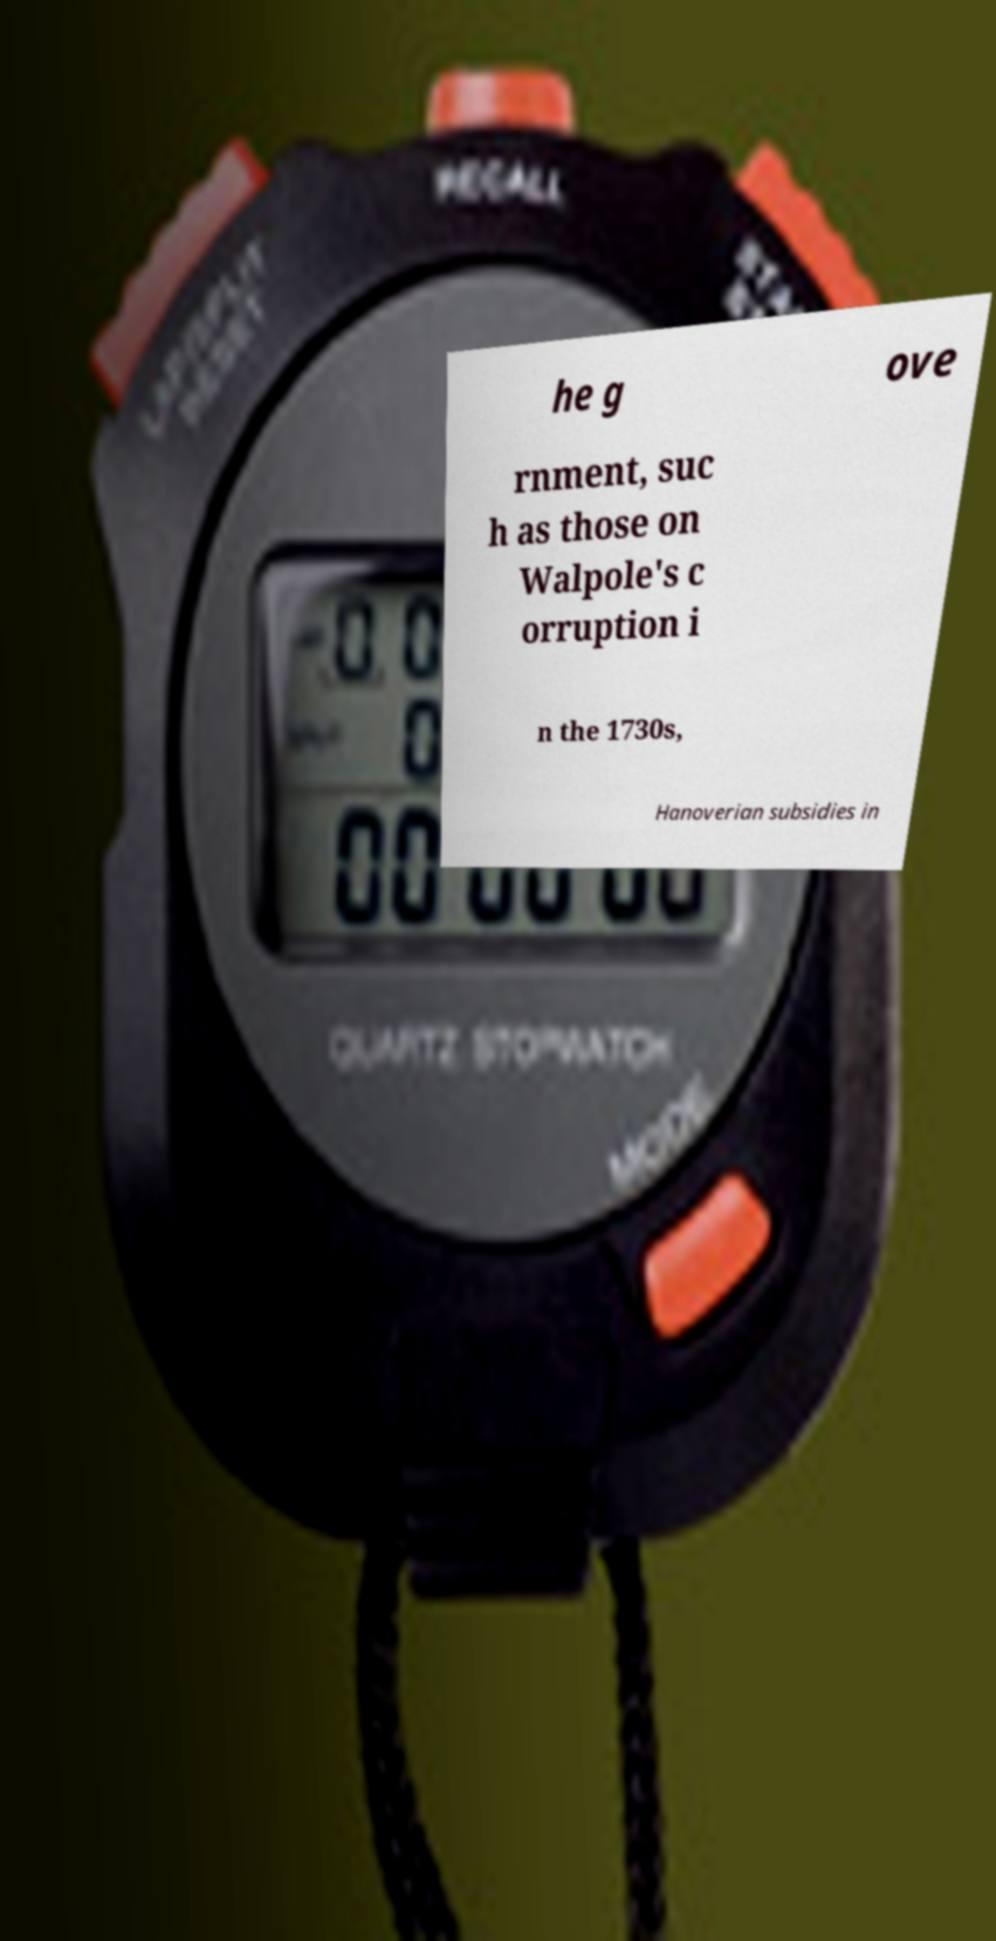Can you read and provide the text displayed in the image?This photo seems to have some interesting text. Can you extract and type it out for me? he g ove rnment, suc h as those on Walpole's c orruption i n the 1730s, Hanoverian subsidies in 